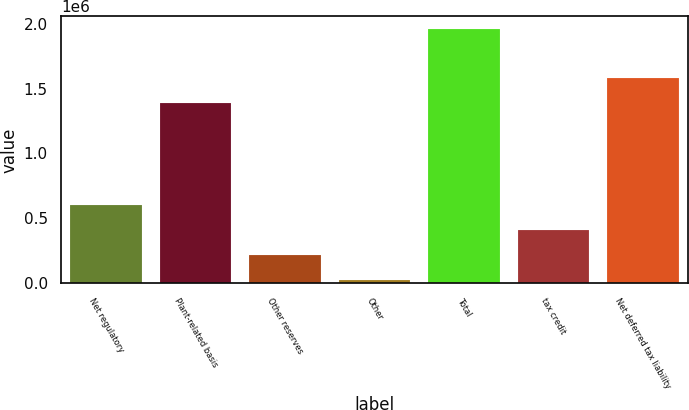Convert chart. <chart><loc_0><loc_0><loc_500><loc_500><bar_chart><fcel>Net regulatory<fcel>Plant-related basis<fcel>Other reserves<fcel>Other<fcel>Total<fcel>tax credit<fcel>Net deferred tax liability<nl><fcel>602026<fcel>1.38839e+06<fcel>214529<fcel>20781<fcel>1.95826e+06<fcel>408277<fcel>1.58214e+06<nl></chart> 